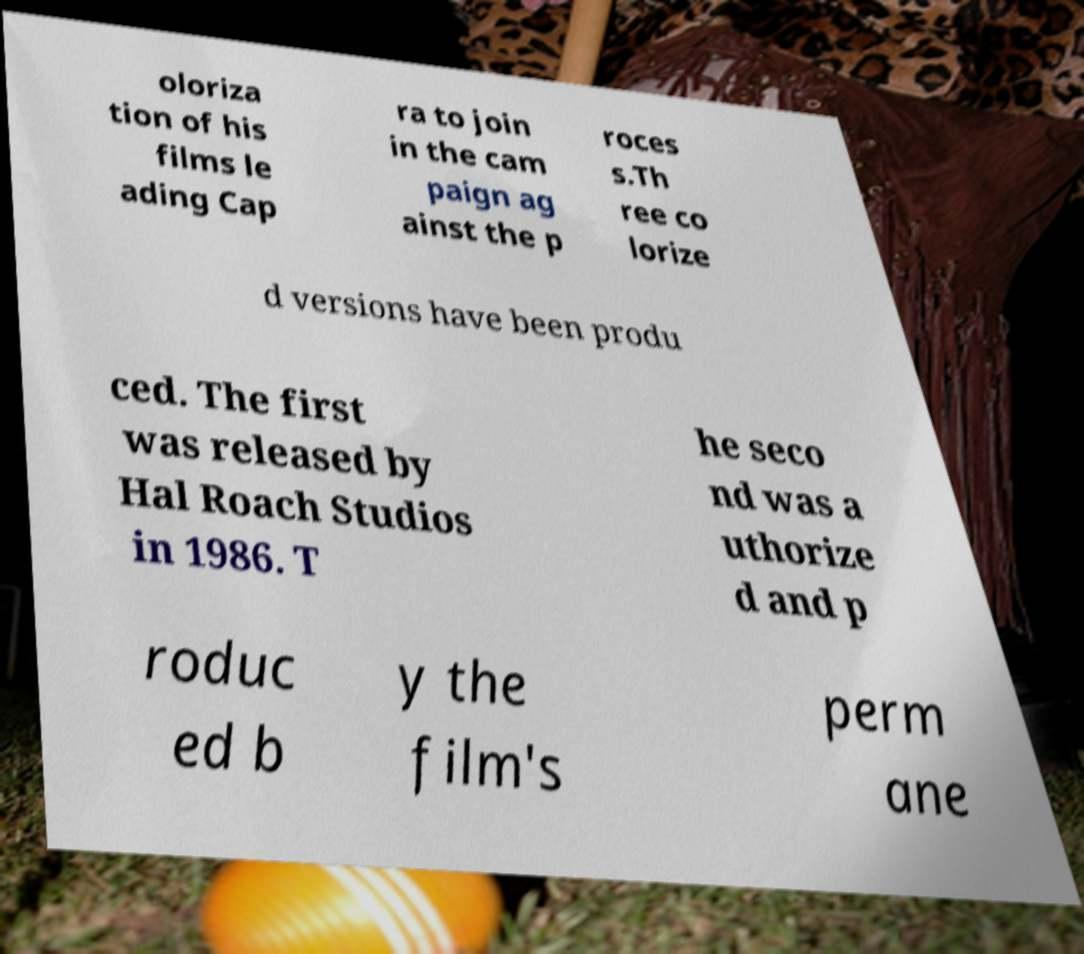I need the written content from this picture converted into text. Can you do that? oloriza tion of his films le ading Cap ra to join in the cam paign ag ainst the p roces s.Th ree co lorize d versions have been produ ced. The first was released by Hal Roach Studios in 1986. T he seco nd was a uthorize d and p roduc ed b y the film's perm ane 